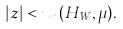Convert formula to latex. <formula><loc_0><loc_0><loc_500><loc_500>| z | < u _ { n } ( H _ { W } , \mu ) .</formula> 